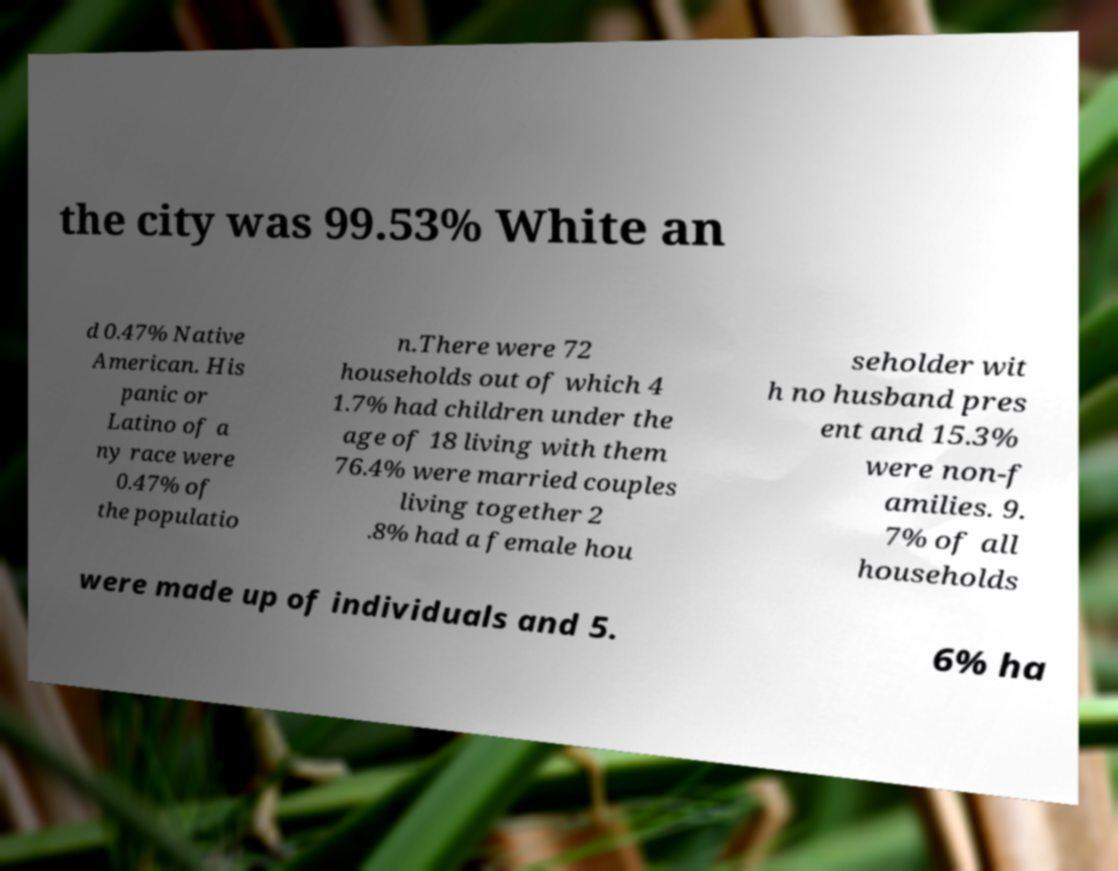There's text embedded in this image that I need extracted. Can you transcribe it verbatim? the city was 99.53% White an d 0.47% Native American. His panic or Latino of a ny race were 0.47% of the populatio n.There were 72 households out of which 4 1.7% had children under the age of 18 living with them 76.4% were married couples living together 2 .8% had a female hou seholder wit h no husband pres ent and 15.3% were non-f amilies. 9. 7% of all households were made up of individuals and 5. 6% ha 